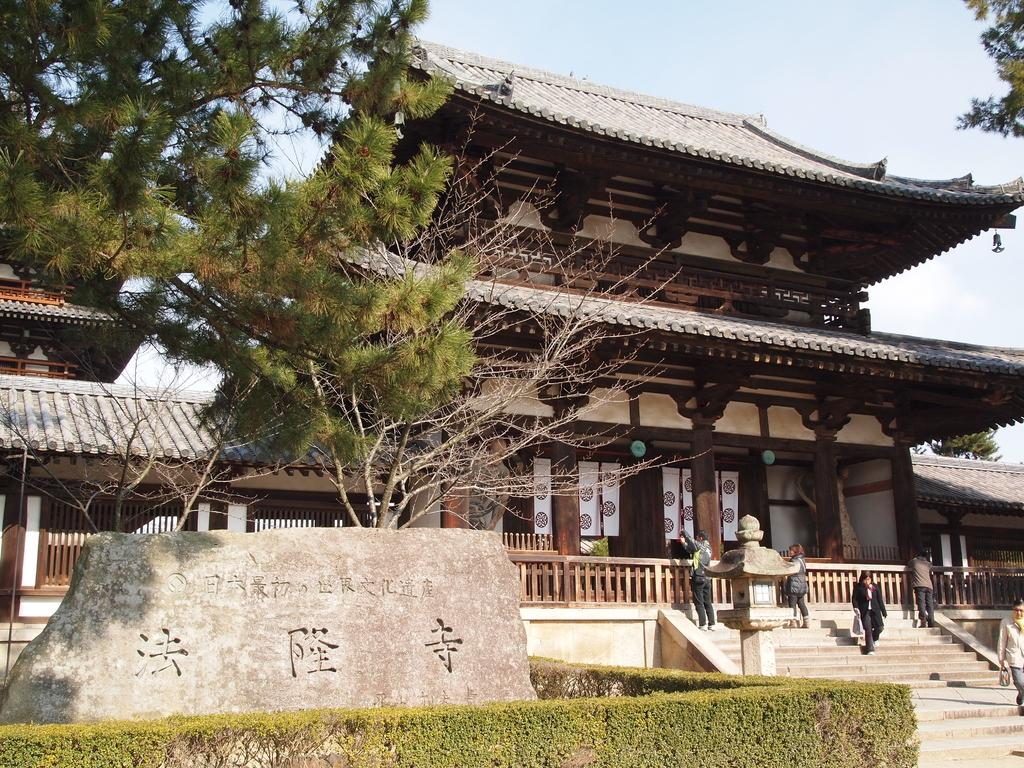What type of structure is present in the image? There is a building in the image. What can be seen on the left side of the image? There is a tree on the left side of the image. What are the people in the image doing? The people in the image are walking. What is visible at the top of the image? The sky is visible at the top of the image. What type of sheet is being used as a sail on the vessel in the image? There is no vessel or sail present in the image; it features a building, a tree, people walking, and the sky. How many quarters are visible on the ground in the image? There are no quarters visible on the ground in the image. 